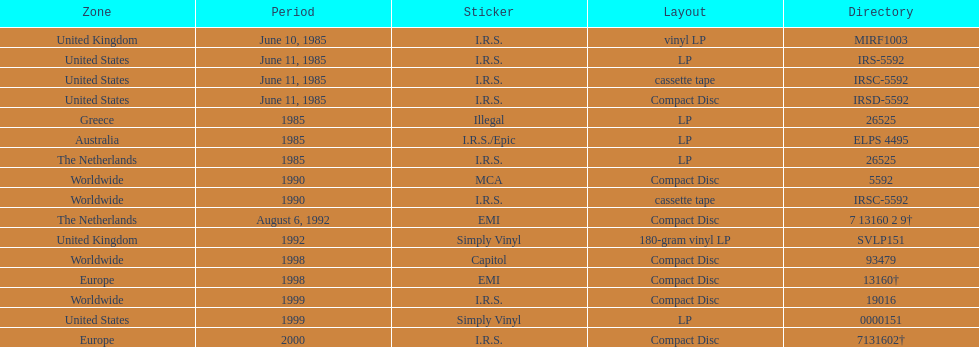Which year had the most releases? 1985. 